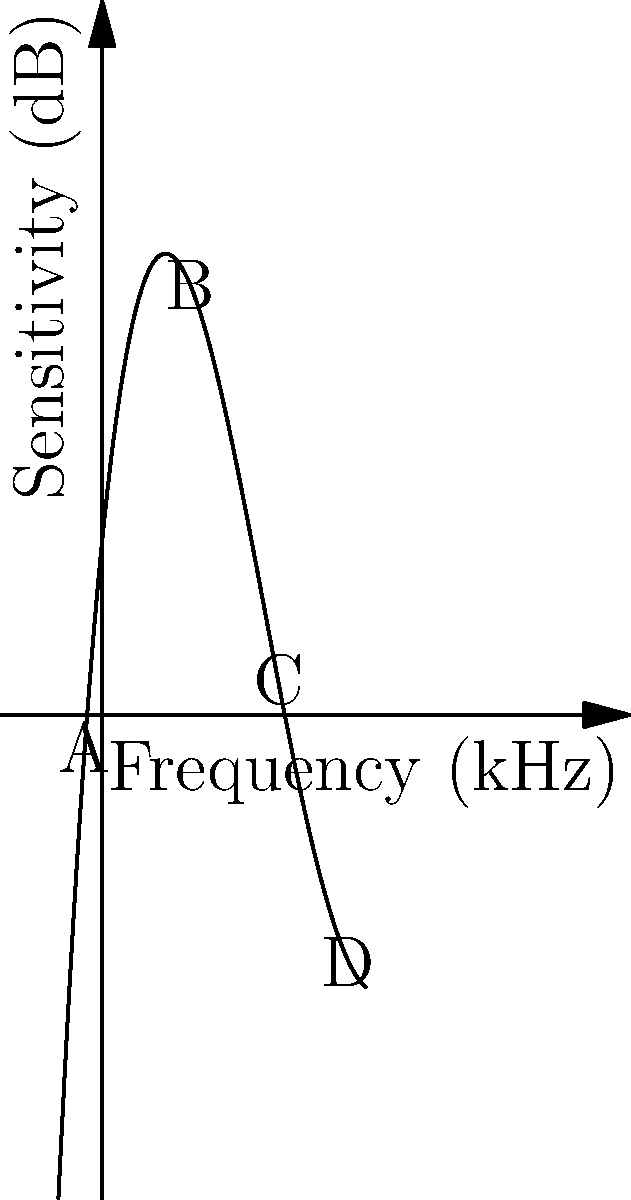The graph represents the sensitivity of the human ear to different frequencies. Which point on the graph corresponds to the frequency range where the human ear is most sensitive, and what does this imply for hearing aid design? To answer this question, we need to analyze the graph and understand its implications:

1. The x-axis represents frequency in kHz, and the y-axis represents sensitivity in dB.
2. The curve shows how sensitive the human ear is to different frequencies.
3. The highest point on the curve represents the frequency range where the ear is most sensitive.
4. Examining the graph, we can see that point B is at the peak of the curve.
5. Point B corresponds to a frequency of around 2-4 kHz.
6. This means the human ear is most sensitive to sounds in this frequency range.
7. For hearing aid design, this implies:
   a) Hearing aids should amplify frequencies around 2-4 kHz less than other frequencies.
   b) More amplification may be needed for frequencies outside this range.
   c) The design should focus on maintaining clarity in this sensitive range while boosting other frequencies.
Answer: Point B; design hearing aids to amplify less at 2-4 kHz, focus on other frequencies. 